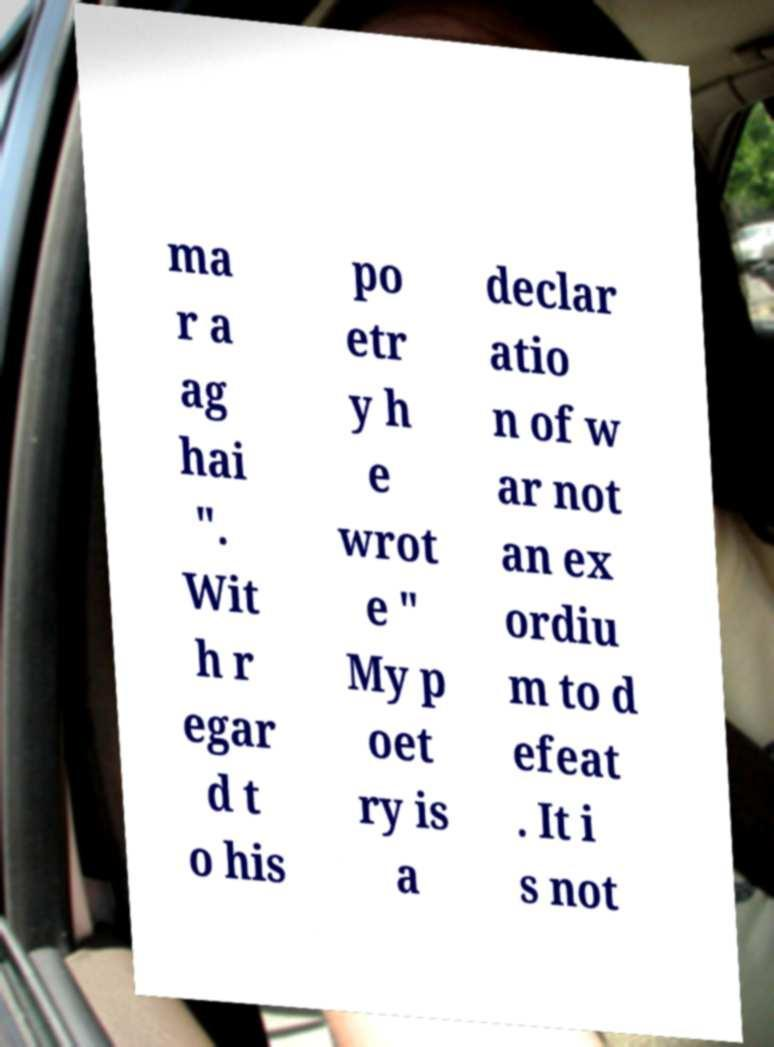Can you accurately transcribe the text from the provided image for me? ma r a ag hai ". Wit h r egar d t o his po etr y h e wrot e " My p oet ry is a declar atio n of w ar not an ex ordiu m to d efeat . It i s not 